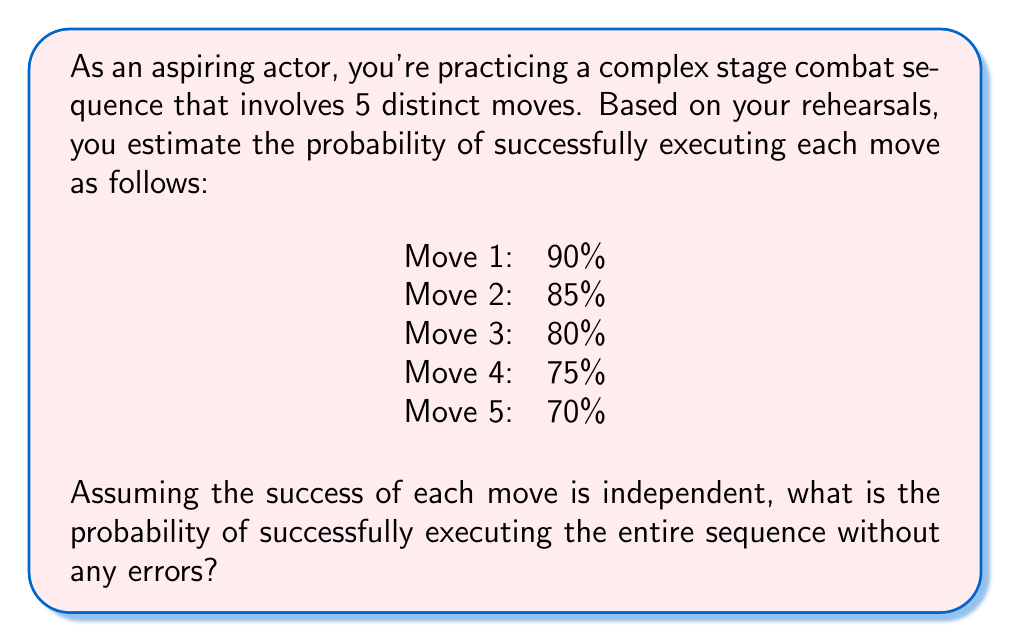What is the answer to this math problem? To solve this problem, we'll use the concept of independent events in probability theory.

1) For independent events, the probability of all events occurring is the product of the individual probabilities of each event.

2) Let's define our events:
   $A_1$ = Success of Move 1
   $A_2$ = Success of Move 2
   $A_3$ = Success of Move 3
   $A_4$ = Success of Move 4
   $A_5$ = Success of Move 5

3) We want to find $P(A_1 \cap A_2 \cap A_3 \cap A_4 \cap A_5)$

4) Given the independence of events:

   $P(A_1 \cap A_2 \cap A_3 \cap A_4 \cap A_5) = P(A_1) \times P(A_2) \times P(A_3) \times P(A_4) \times P(A_5)$

5) Substituting the given probabilities:

   $P(\text{Success}) = 0.90 \times 0.85 \times 0.80 \times 0.75 \times 0.70$

6) Calculating:

   $P(\text{Success}) = 0.3213 = 32.13\%$

Therefore, the probability of successfully executing the entire sequence without any errors is approximately 32.13%.
Answer: The probability of successfully executing the entire combat sequence is approximately 32.13%. 